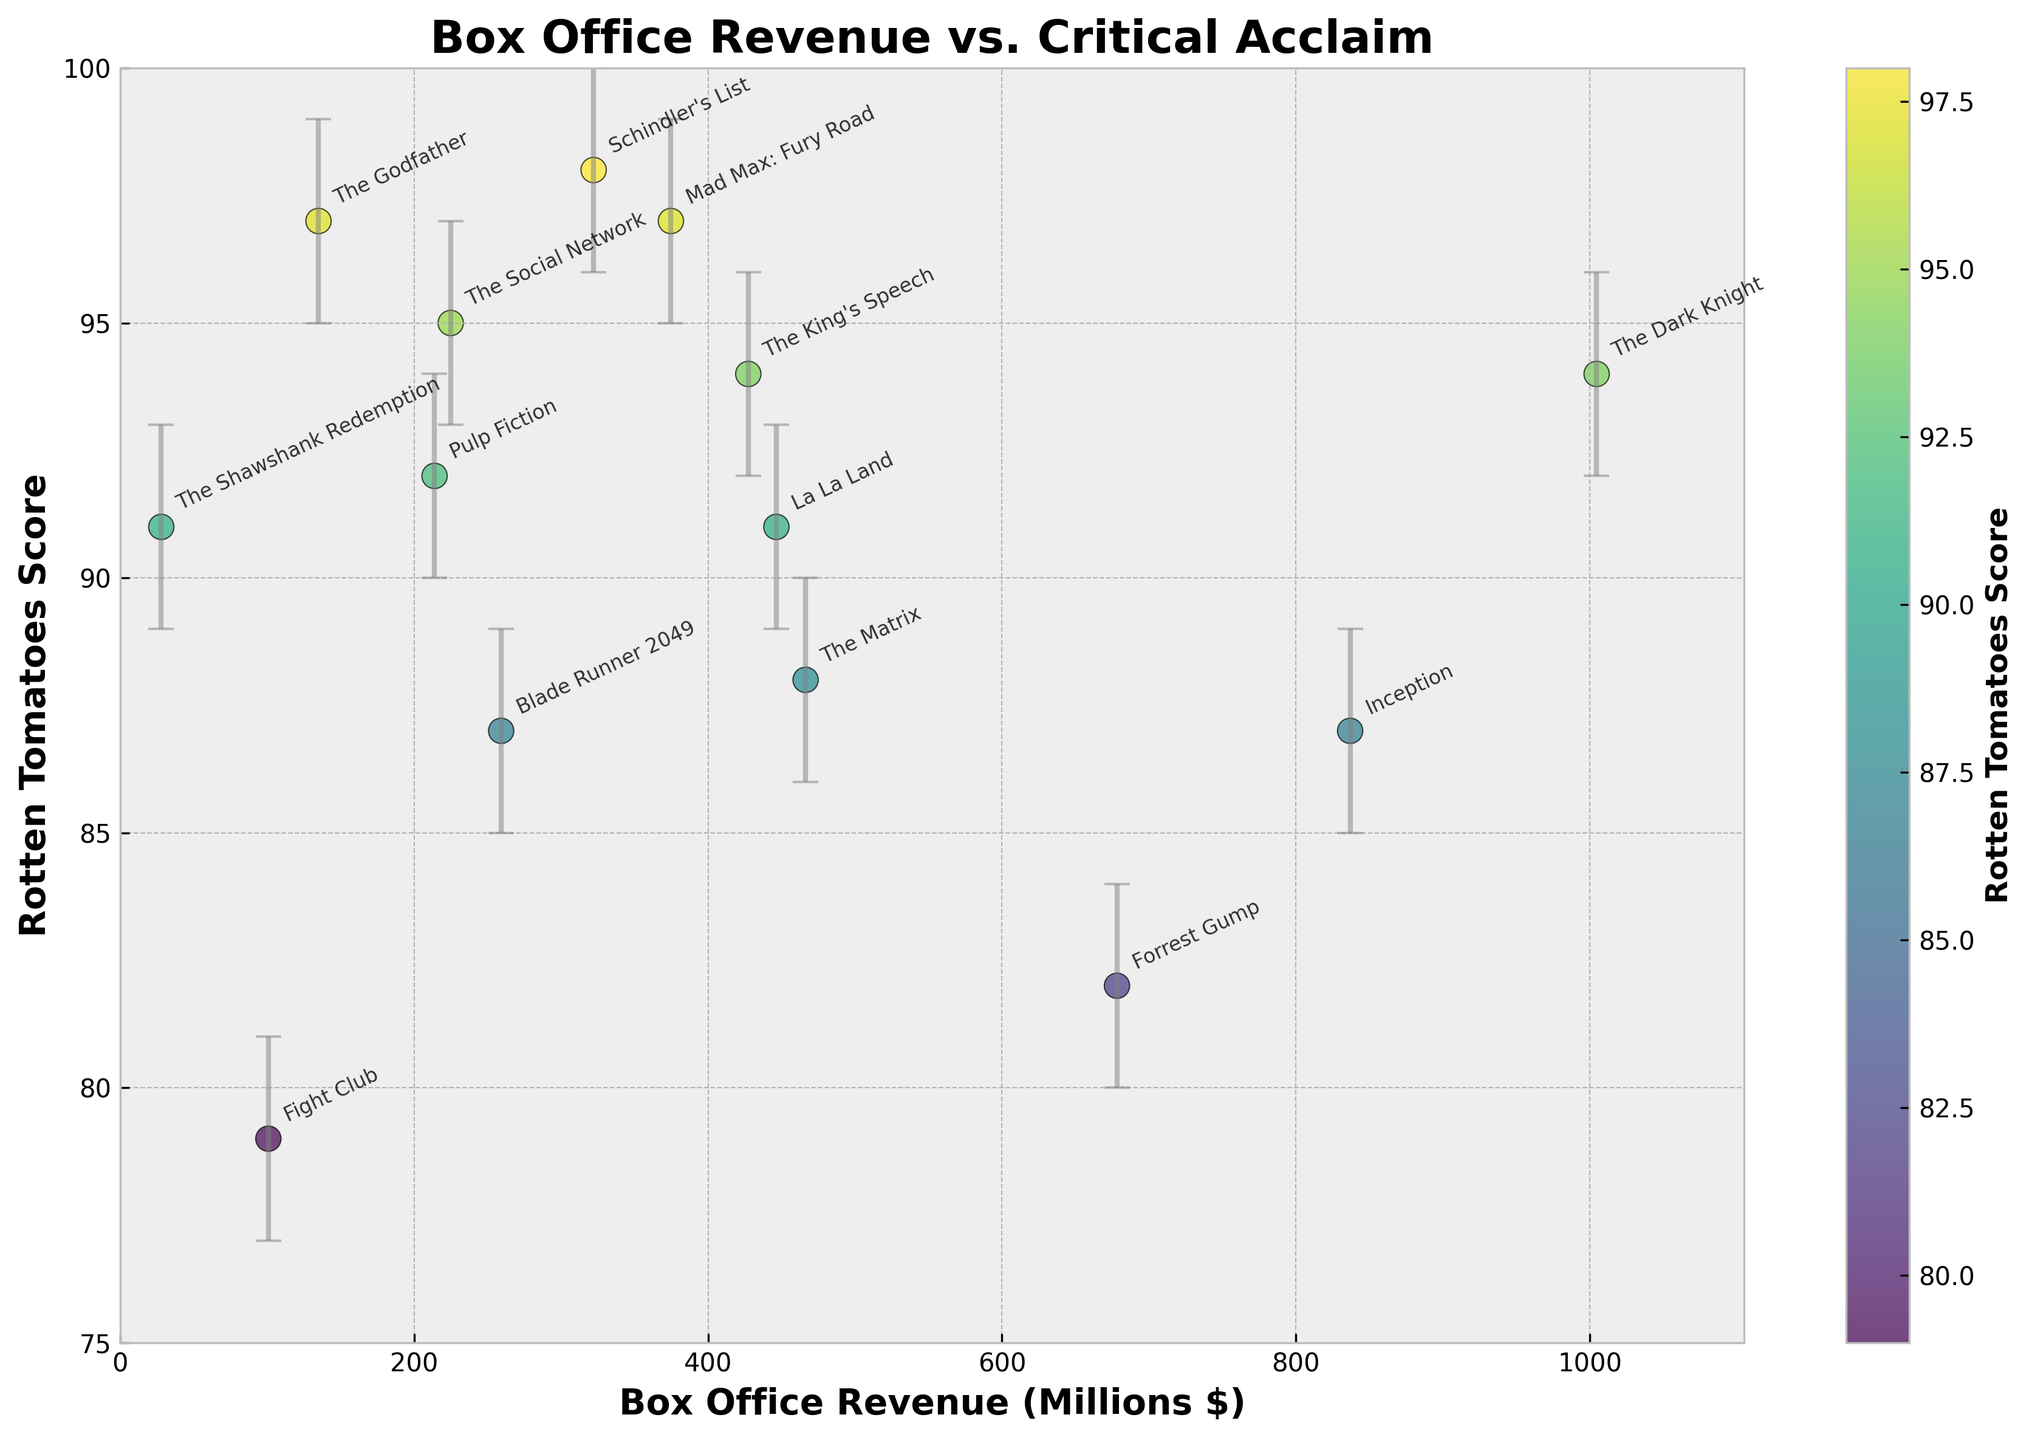What's the title of the plot? The title of the plot is indicated at the top of the figure.
Answer: Box Office Revenue vs. Critical Acclaim What do the x and y axes represent? The x-axis represents the Box Office Revenue in millions of dollars, and the y-axis represents the Rotten Tomatoes Score.
Answer: Box Office Revenue (Millions $), Rotten Tomatoes Score Which movie has the highest box office revenue? By observing the x-axis, the movie that is located farthest to the right on the plot has the highest box office revenue.
Answer: The Dark Knight Which movie has the highest Rotten Tomatoes score? By observing the y-axis, the movie that is positioned highest on the plot has the highest Rotten Tomatoes score.
Answer: Schindler's List Which movie has the widest confidence interval in its Rotten Tomatoes score? The width of the confidence intervals is indicated by the length of the error bars on the y-axis. The movie with the longest error bar has the widest confidence interval.
Answer: Schindler's List Which movies have a Rotten Tomatoes score of 91? The movies with a score of 91 are positioned at the same y-value of 91 on the plot.
Answer: The Shawshank Redemption, La La Land Which movie has the lowest Rotten Tomatoes score? By observing the y-axis, the movie that is positioned lowest on the plot has the lowest Rotten Tomatoes score.
Answer: Fight Club What is the difference in box office revenue between The Dark Knight and Forrest Gump? The box office revenue for The Dark Knight is about $1,004.56M, and for Forrest Gump, it is about $678.23M. The difference is calculated by subtracting the smaller revenue from the larger revenue.
Answer: Approximately $326.33M Which movie with a Rotten Tomatoes score of 94 has the higher box office revenue? Compare the box office revenue values (x-axis) of the movies that have a Rotten Tomatoes score of 94.
Answer: The Dark Knight How many movies have a box office revenue greater than $500 million? Count the number of points positioned to the right of the $500 million mark on the x-axis.
Answer: 4 movies Which movie falls in the range of a box office revenue between $200 million and $300 million with a Rotten Tomatoes score of 87? Identify the point that lies within the x-axis range of $200 million to $300 million and has a y-value of 87.
Answer: Blade Runner 2049 